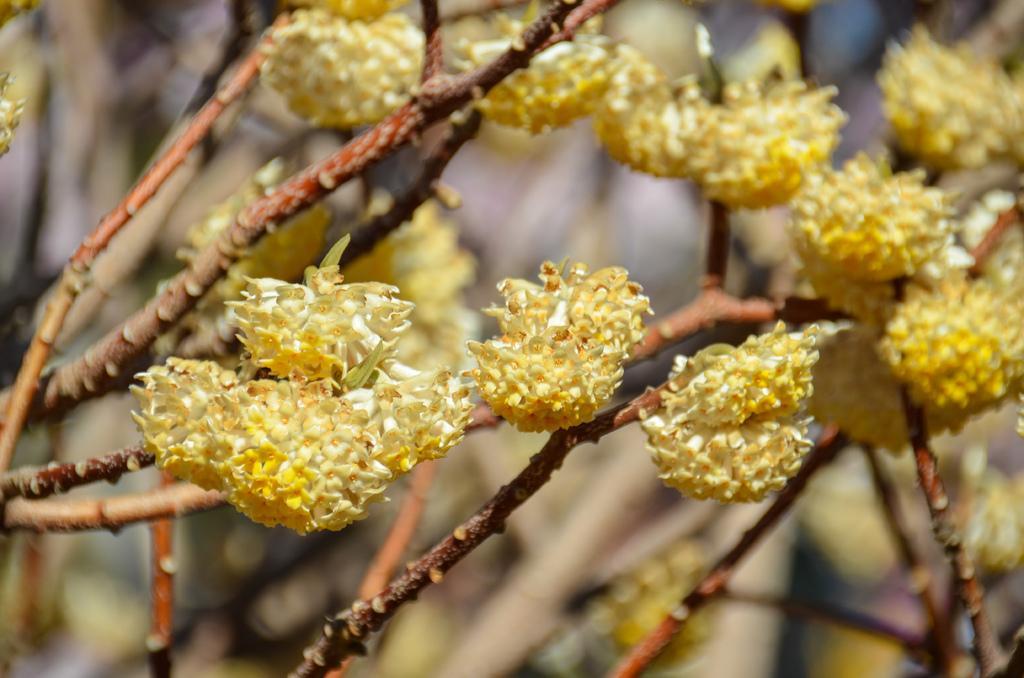Please provide a concise description of this image. In this image I can see a tree to which I can see few flowers which are yellow in color and I can see the blurry background. 